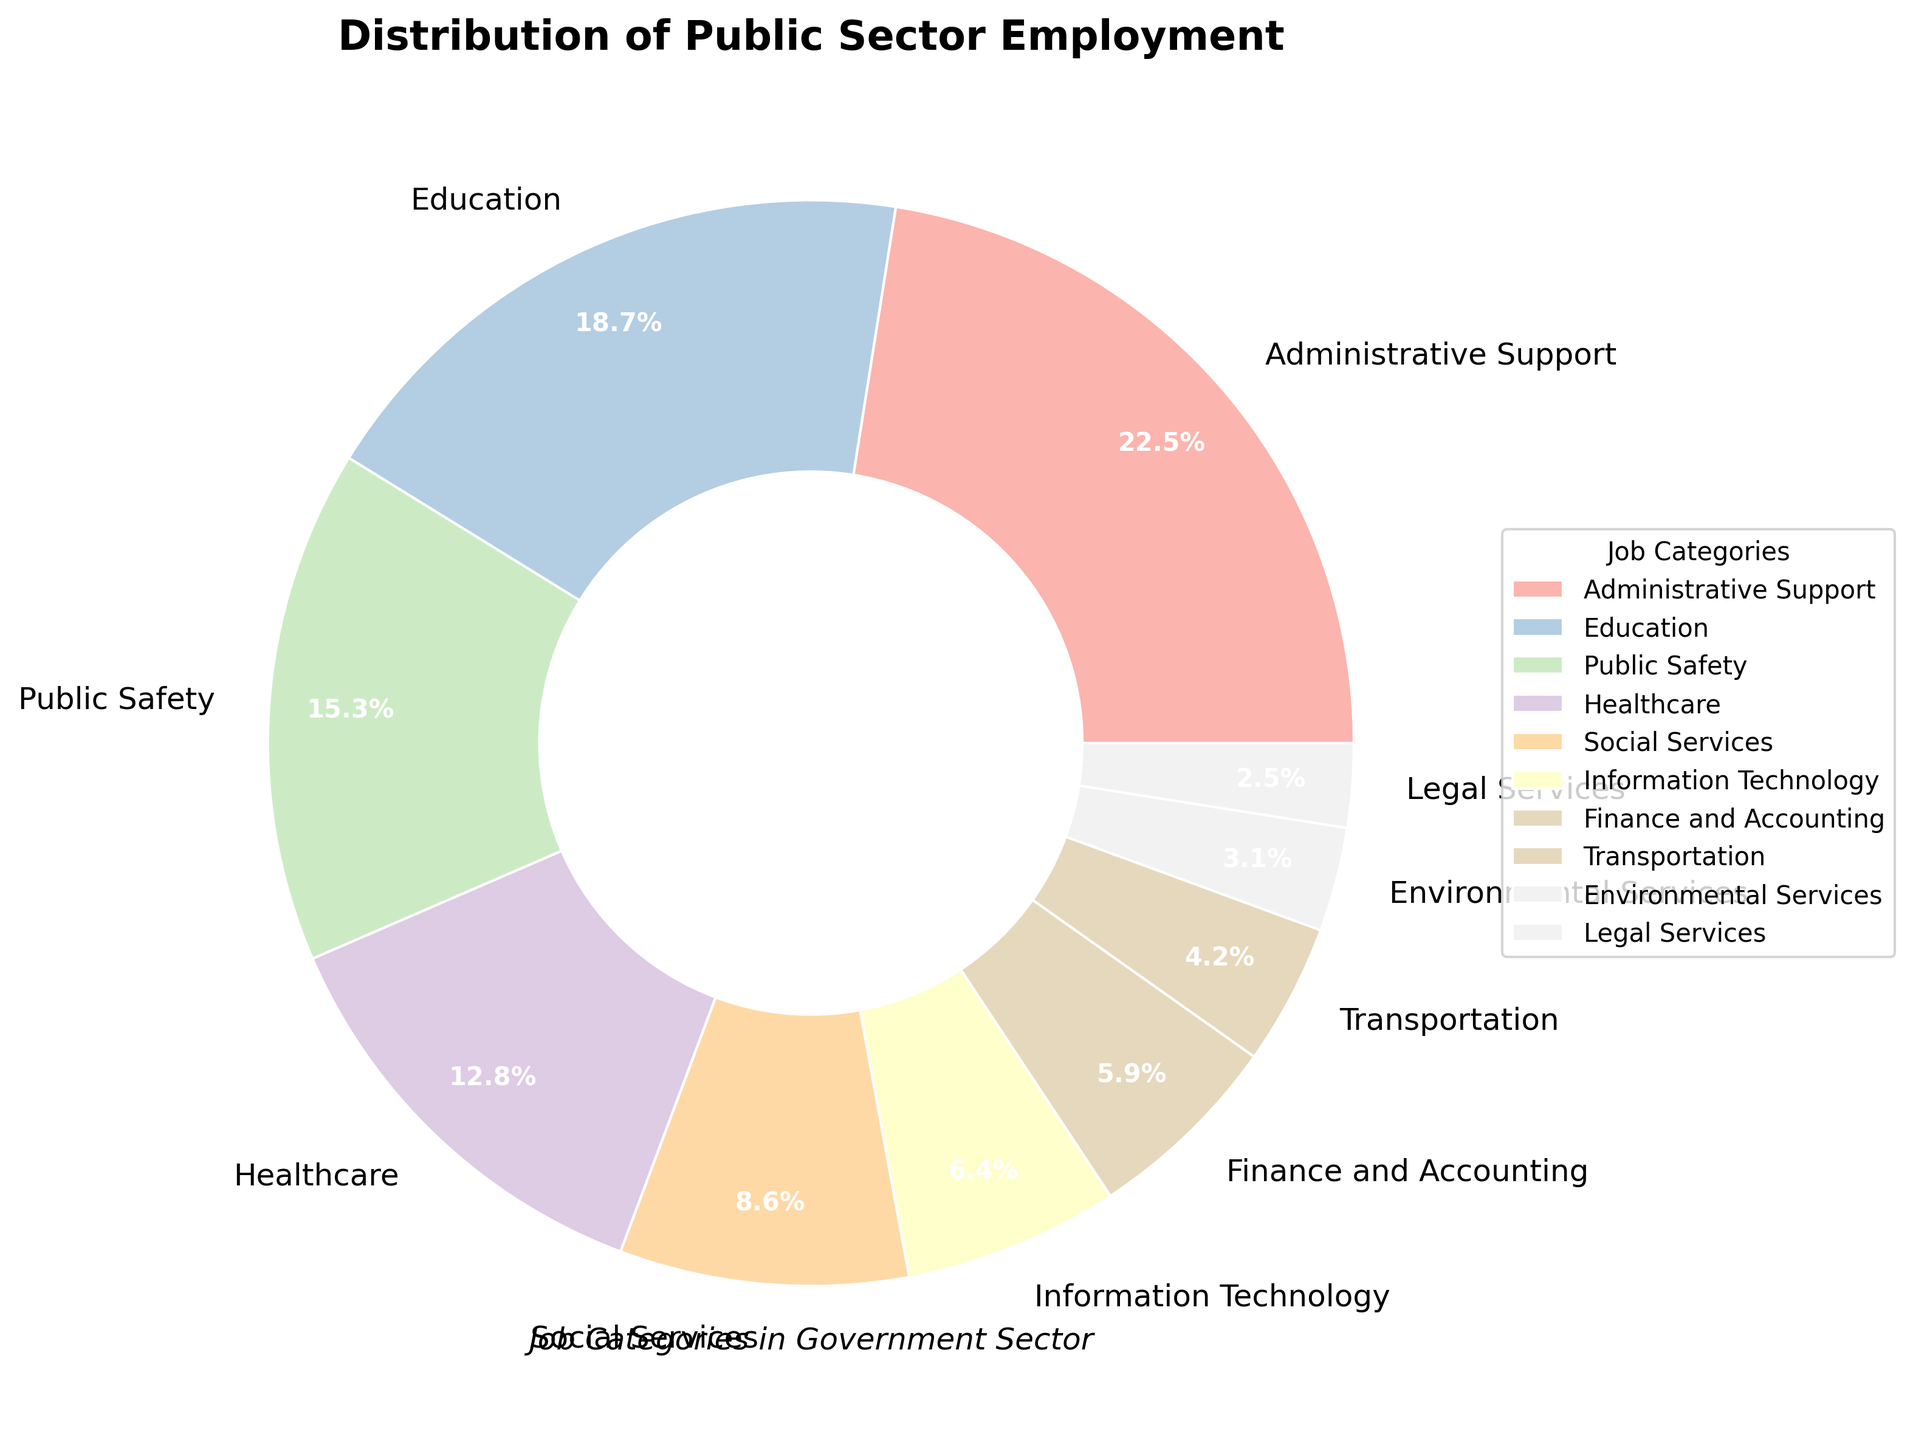What's the most common job category in public sector employment? The most common job category is the one with the highest percentage in the pie chart. By looking at the chart, we see that Administrative Support has the largest share at 22.5%.
Answer: Administrative Support What is the combined percentage of Healthcare and Education employment? To find the combined percentage, sum the percentages of Healthcare and Education. Healthcare is 12.8% and Education is 18.7%. So, 12.8% + 18.7% = 31.5%.
Answer: 31.5% Which job category is the least common in public sector employment? The least common job category is the one with the smallest percentage in the pie chart. Legal Services has the smallest share at 2.5%.
Answer: Legal Services How does the percentage of Public Safety compare to Finance and Accounting? Public Safety has a percentage of 15.3% while Finance and Accounting has 5.9%. By comparing these, we see that Public Safety is greater than Finance and Accounting.
Answer: Public Safety is greater What is the total percentage of job categories that have less than 10% employment each? Identify the job categories with percentages less than 10% and then sum them: Social Services (8.6%), Information Technology (6.4%), Finance and Accounting (5.9%), Transportation (4.2%), Environmental Services (3.1%), Legal Services (2.5%). The total is 8.6% + 6.4% + 5.9% + 4.2% + 3.1% + 2.5% = 30.7%.
Answer: 30.7% What is the visual color assigned to the Healthcare category? By looking at the pie chart, the color associated with Healthcare can be identified visually. It is a unique color within the pie slices.
Answer: Color for Healthcare (depends on chart) Which job category is visually represented by the largest slice of the pie? The largest slice in the pie chart corresponds to the category with the highest percentage. This category is Administrative Support with 22.5%.
Answer: Administrative Support How does Education's slice size compare to Administrative Support's slice size? The slice for Education (18.7%) is smaller than the slice for Administrative Support (22.5%), which means Administrative Support's slice is larger.
Answer: Smaller If Information Technology and Legal Services percentages were combined, would they equal or exceed Healthcare's percentage? Sum the percentages of Information Technology (6.4%) and Legal Services (2.5%), which gives 6.4% + 2.5% = 8.9%. Compare this to Healthcare's 12.8%. Since 8.9% is less than 12.8%, they do not equal or exceed Healthcare's percentage.
Answer: No, they don’t exceed What is the difference between the employment percentages of the Education and Public Safety categories? Subtract the percentage of Public Safety (15.3%) from the percentage of Education (18.7%). So, 18.7% - 15.3% = 3.4%.
Answer: 3.4% 